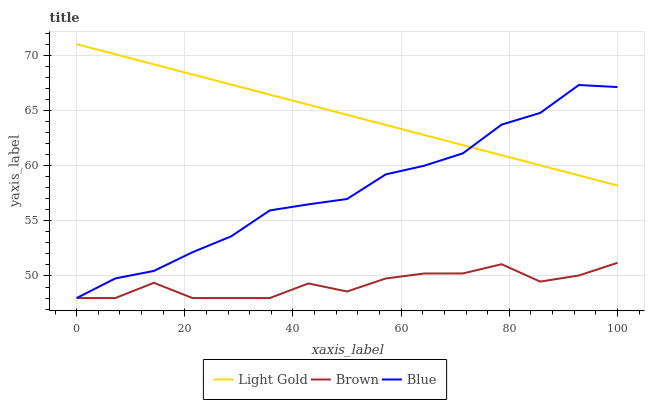Does Brown have the minimum area under the curve?
Answer yes or no. Yes. Does Light Gold have the maximum area under the curve?
Answer yes or no. Yes. Does Light Gold have the minimum area under the curve?
Answer yes or no. No. Does Brown have the maximum area under the curve?
Answer yes or no. No. Is Light Gold the smoothest?
Answer yes or no. Yes. Is Brown the roughest?
Answer yes or no. Yes. Is Brown the smoothest?
Answer yes or no. No. Is Light Gold the roughest?
Answer yes or no. No. Does Blue have the lowest value?
Answer yes or no. Yes. Does Light Gold have the lowest value?
Answer yes or no. No. Does Light Gold have the highest value?
Answer yes or no. Yes. Does Brown have the highest value?
Answer yes or no. No. Is Brown less than Light Gold?
Answer yes or no. Yes. Is Light Gold greater than Brown?
Answer yes or no. Yes. Does Blue intersect Light Gold?
Answer yes or no. Yes. Is Blue less than Light Gold?
Answer yes or no. No. Is Blue greater than Light Gold?
Answer yes or no. No. Does Brown intersect Light Gold?
Answer yes or no. No. 